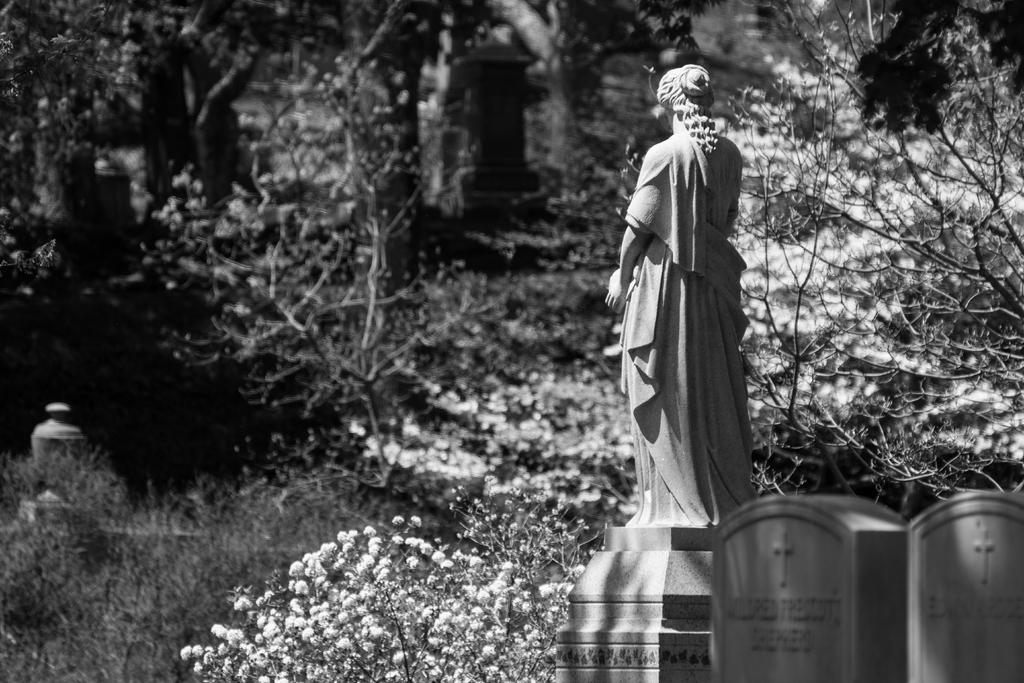What is the main subject in the image? There is a statue in the image. What type of natural elements can be seen in the image? There are trees in the image. What other objects are present in the image? There are gravestones in the image. What type of toad can be seen sitting on the statue in the image? There is no toad present on the statue in the image. What type of beam is holding up the statue in the image? The image does not show any beams supporting the statue; it is standing on its own or on a base. 